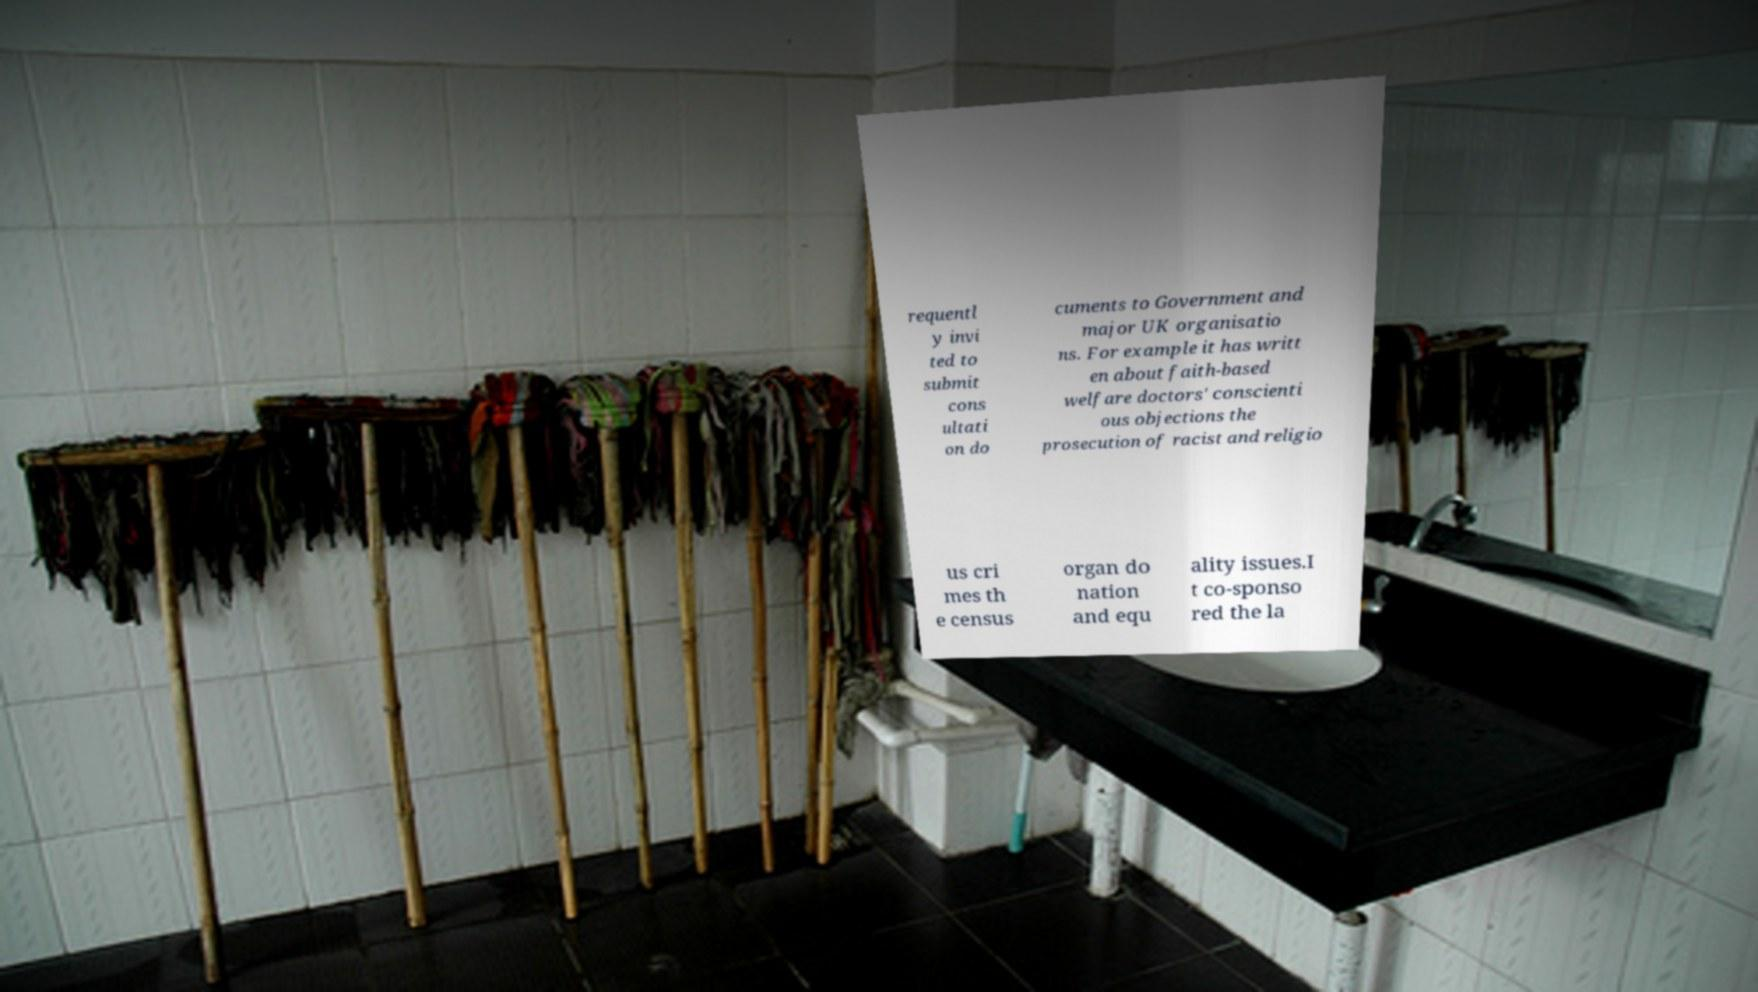Please identify and transcribe the text found in this image. requentl y invi ted to submit cons ultati on do cuments to Government and major UK organisatio ns. For example it has writt en about faith-based welfare doctors' conscienti ous objections the prosecution of racist and religio us cri mes th e census organ do nation and equ ality issues.I t co-sponso red the la 